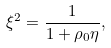<formula> <loc_0><loc_0><loc_500><loc_500>\xi ^ { 2 } = \frac { 1 } { 1 + \rho _ { 0 } \eta } ,</formula> 